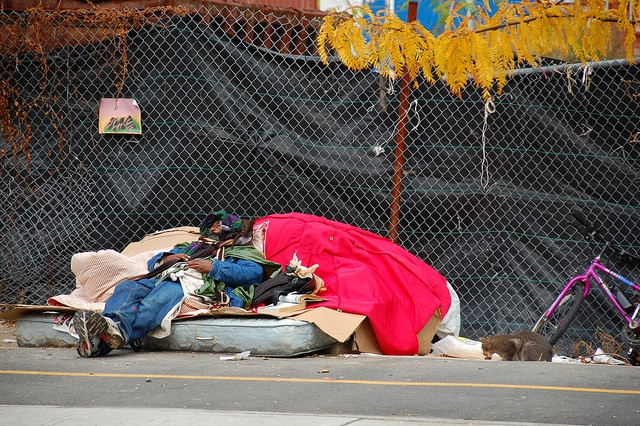Describe the objects in this image and their specific colors. I can see people in black, blue, gray, and lightgray tones, bed in black, darkgray, gray, and lightgray tones, bicycle in black, gray, and purple tones, and cat in black, gray, and maroon tones in this image. 